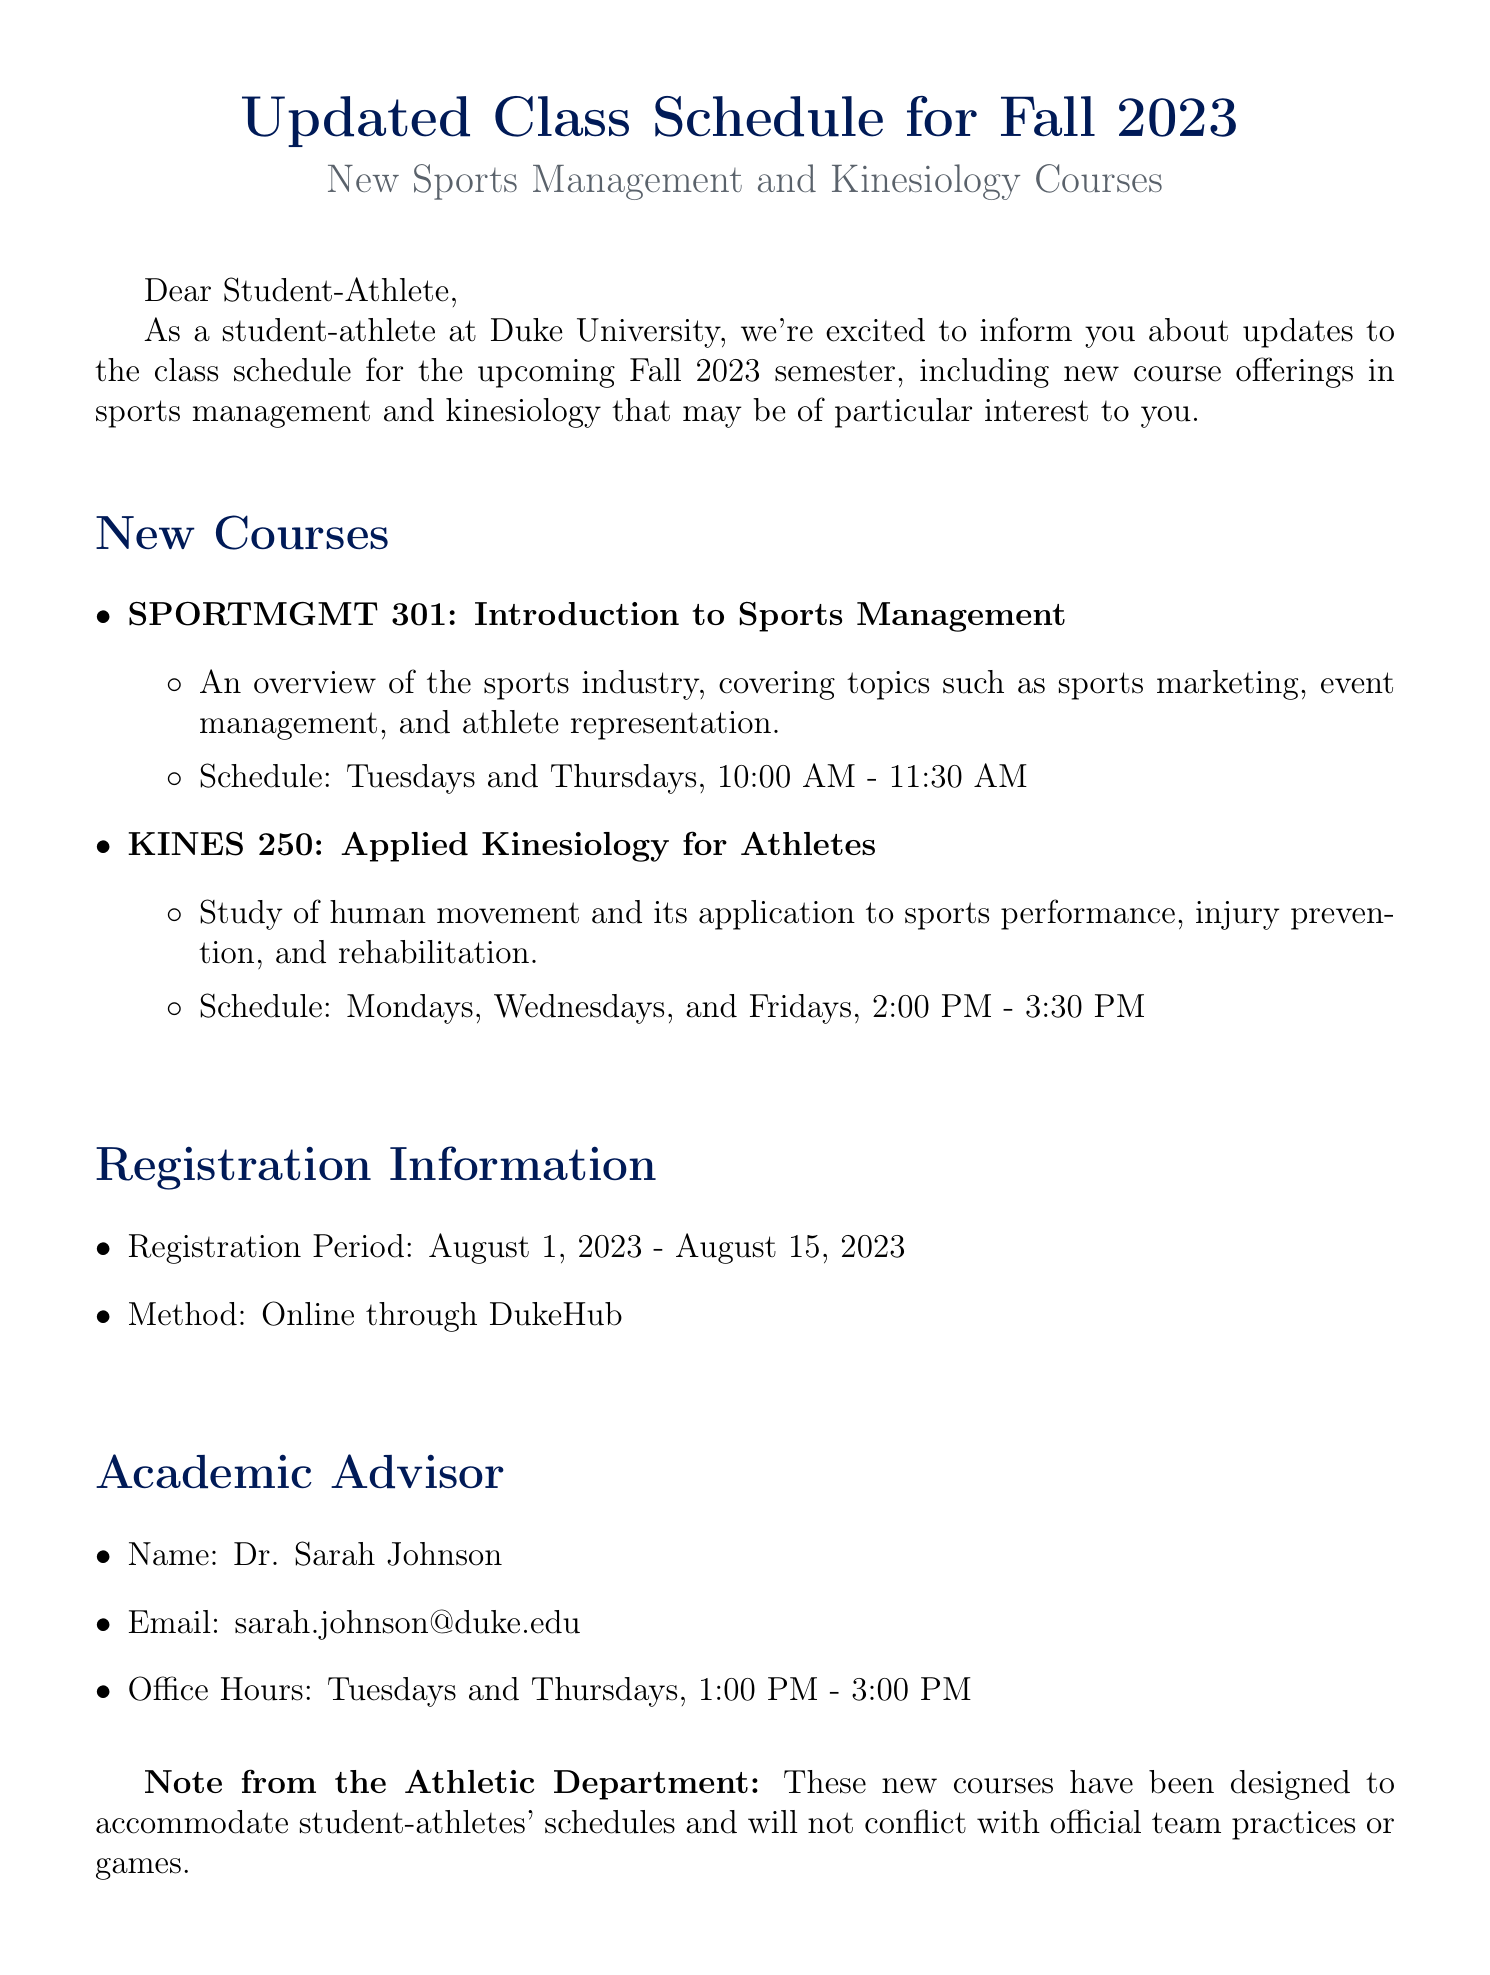What is the start date for registration? The start date for registration is specified in the document under registration information.
Answer: August 1, 2023 What is the course code for "Applied Kinesiology for Athletes"? The document lists the course details including the code for each course.
Answer: KINES 250 Who is the academic advisor mentioned in the email? The document provides the name of the academic advisor along with contact information.
Answer: Dr. Sarah Johnson How many times a week is "Introduction to Sports Management" held? The schedule of the course specifies how often it is held per week.
Answer: Two times What is the email address of the academic advisor? The advisor's contact details, including email, are provided in the document.
Answer: sarah.johnson@duke.edu What is the end date for registration? The end date for registration is detailed in the registration information section of the document.
Answer: August 15, 2023 When are the office hours of the academic advisor? The office hours are explicitly mentioned in the academic advisor section of the document.
Answer: Tuesdays and Thursdays, 1:00 PM - 3:00 PM What is one of the topics covered in "Applied Kinesiology for Athletes"? The document mentions specific topics covered in the course description.
Answer: Injury prevention What is the main purpose of the email? The email's introduction outlines its purpose related to class schedules and course offerings.
Answer: Class schedule update 